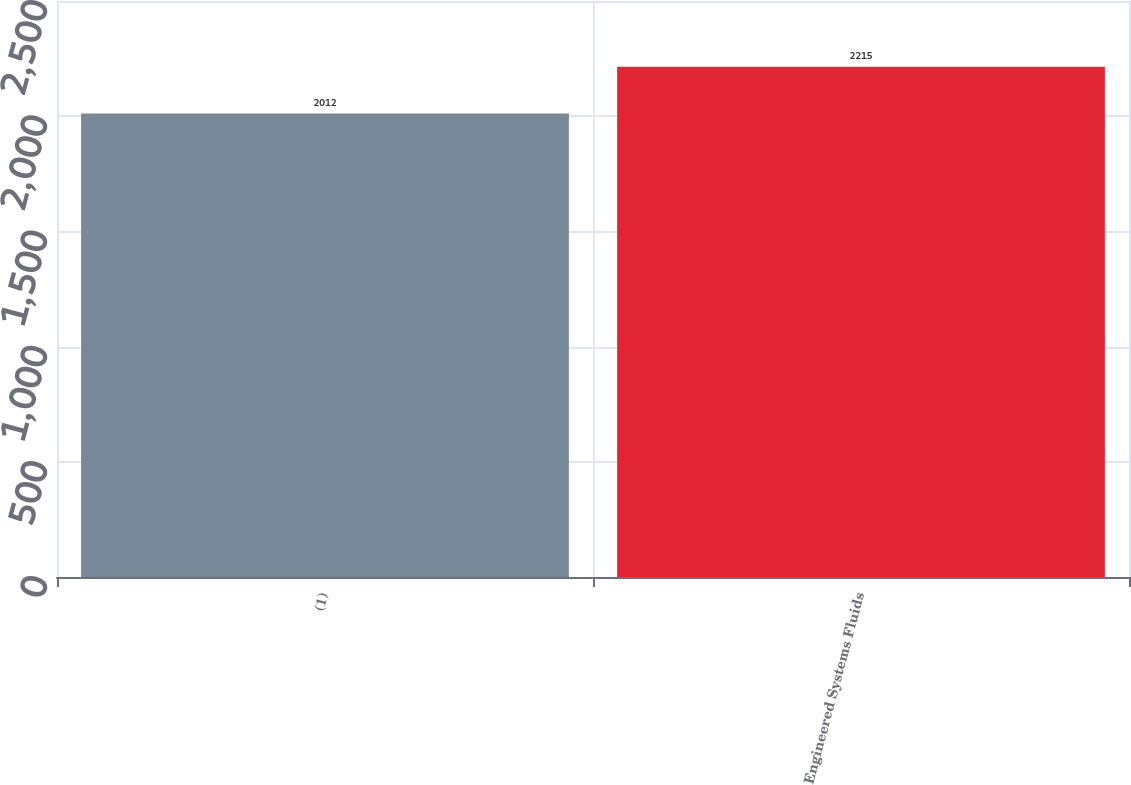Convert chart to OTSL. <chart><loc_0><loc_0><loc_500><loc_500><bar_chart><fcel>(1)<fcel>Engineered Systems Fluids<nl><fcel>2012<fcel>2215<nl></chart> 